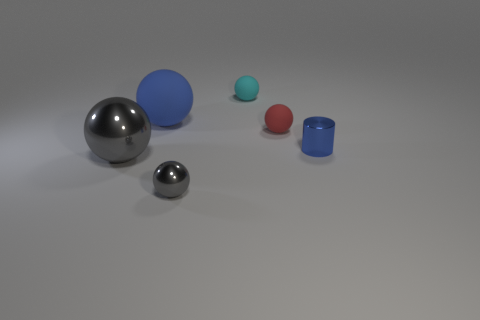Subtract all red rubber balls. How many balls are left? 4 Subtract all blue balls. How many balls are left? 4 Subtract all brown balls. Subtract all brown blocks. How many balls are left? 5 Add 3 tiny cyan things. How many objects exist? 9 Subtract all balls. How many objects are left? 1 Subtract all gray metal balls. Subtract all tiny metallic objects. How many objects are left? 2 Add 2 tiny red rubber balls. How many tiny red rubber balls are left? 3 Add 1 small yellow matte objects. How many small yellow matte objects exist? 1 Subtract 0 red cubes. How many objects are left? 6 